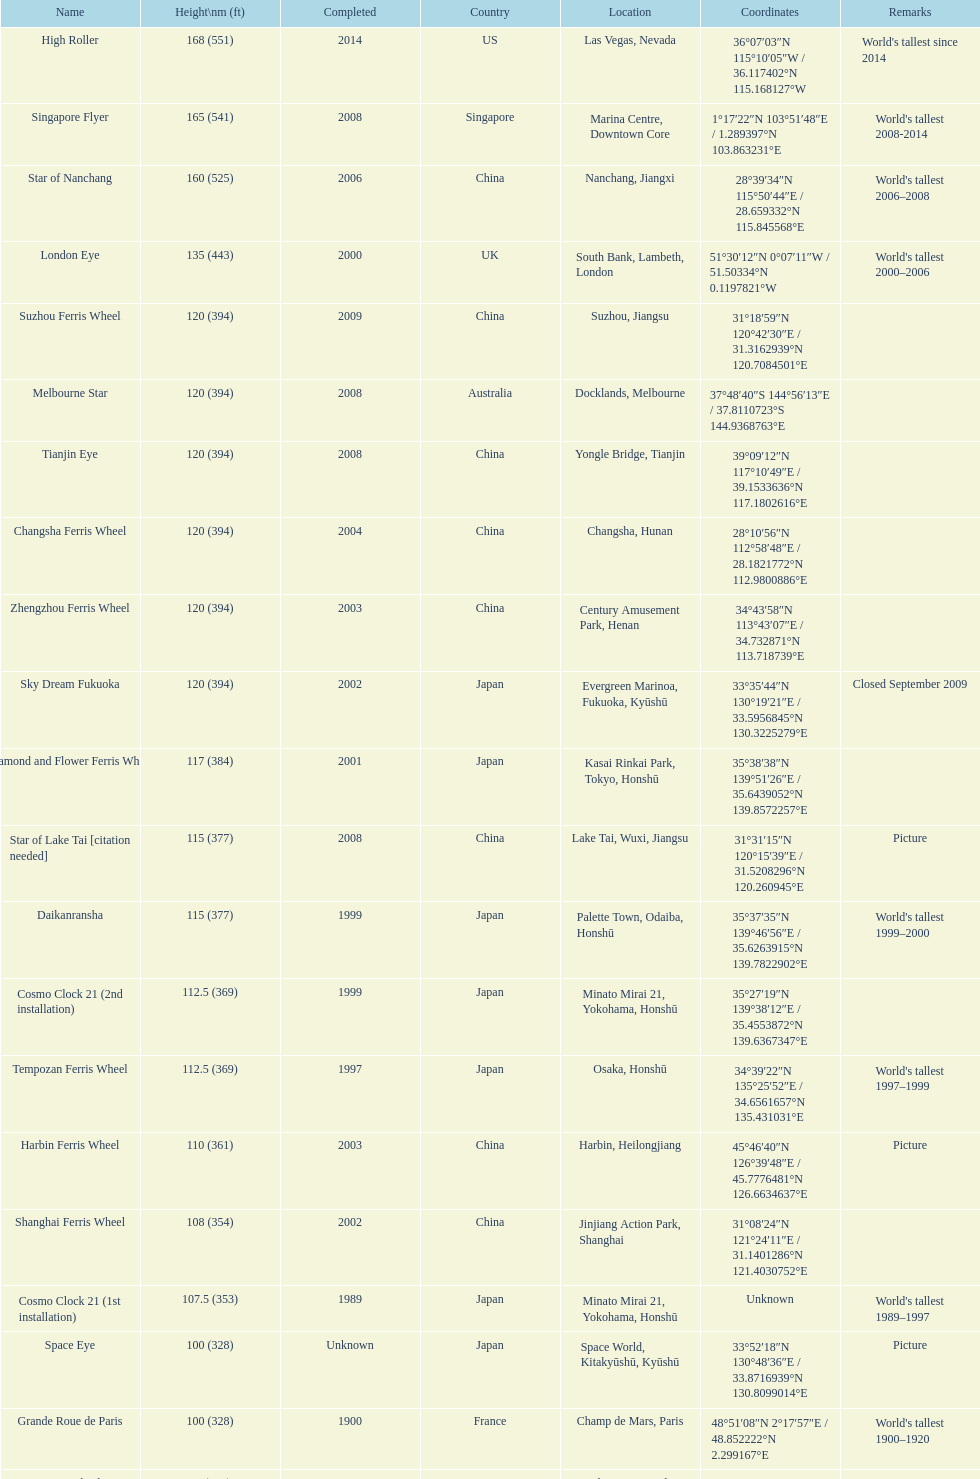Which ferris wheel, standing at 165 meters, was built in 2008? Singapore Flyer. 